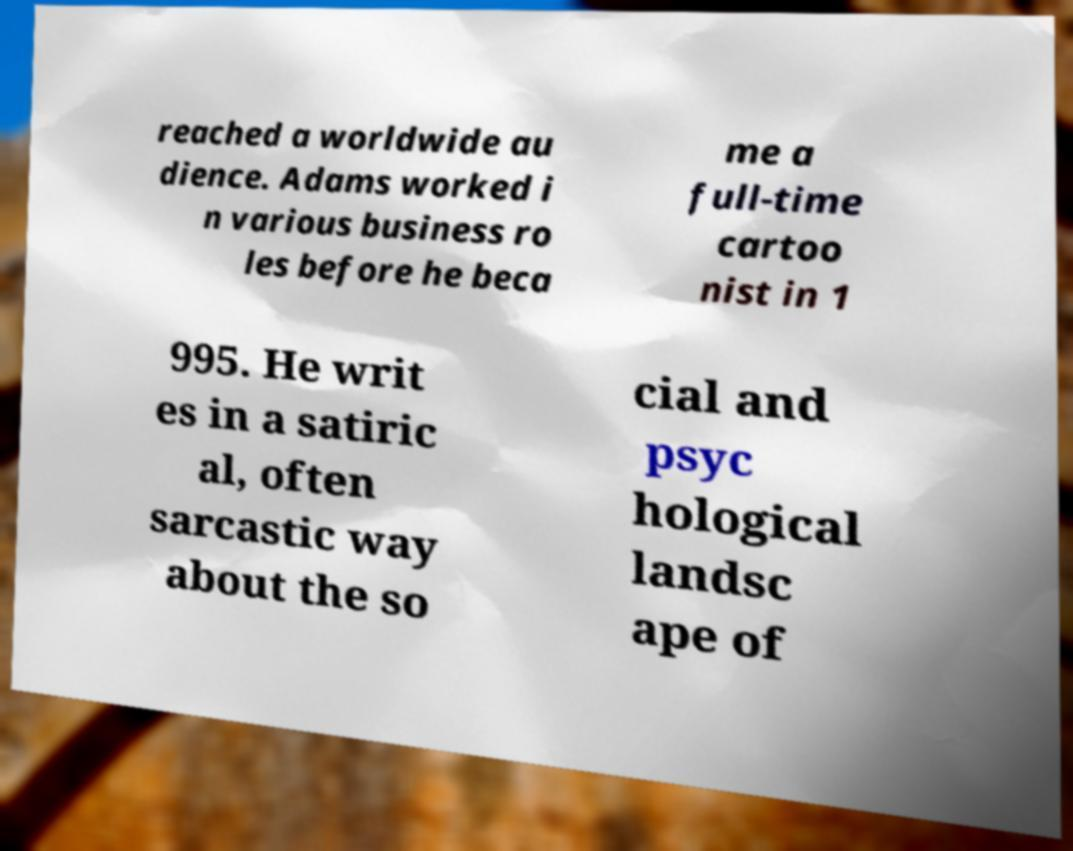Can you accurately transcribe the text from the provided image for me? reached a worldwide au dience. Adams worked i n various business ro les before he beca me a full-time cartoo nist in 1 995. He writ es in a satiric al, often sarcastic way about the so cial and psyc hological landsc ape of 